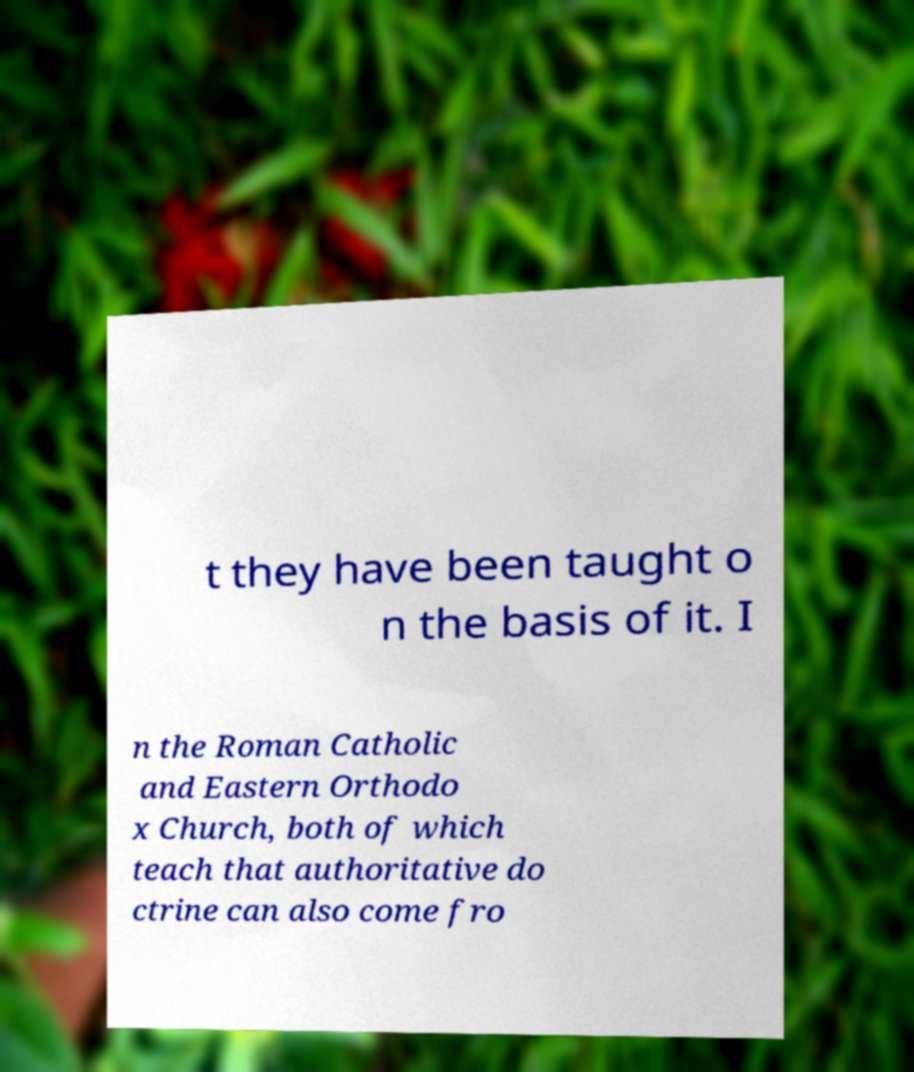I need the written content from this picture converted into text. Can you do that? t they have been taught o n the basis of it. I n the Roman Catholic and Eastern Orthodo x Church, both of which teach that authoritative do ctrine can also come fro 